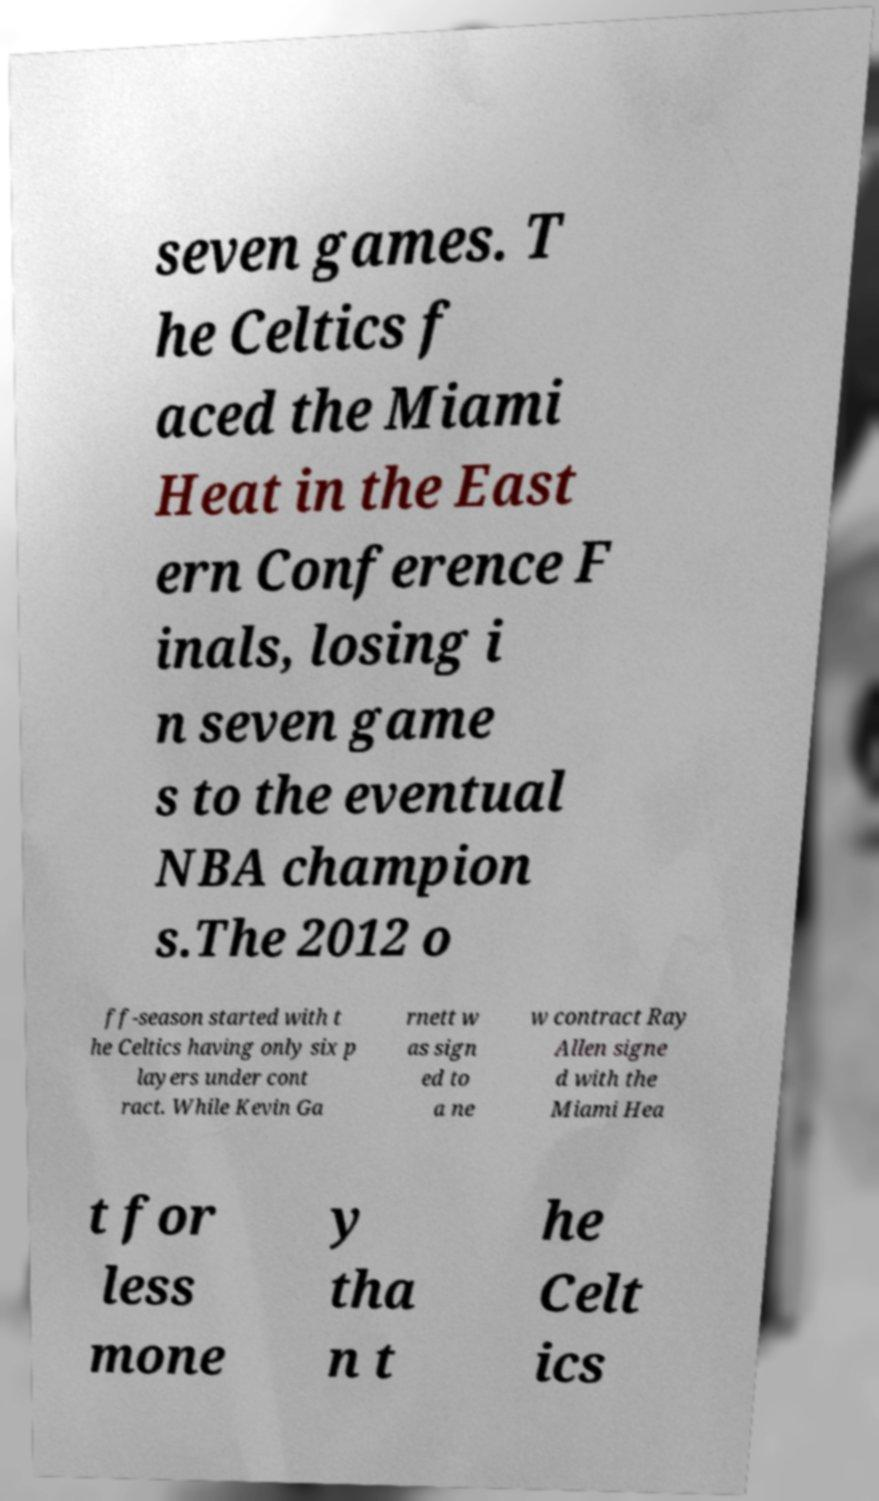There's text embedded in this image that I need extracted. Can you transcribe it verbatim? seven games. T he Celtics f aced the Miami Heat in the East ern Conference F inals, losing i n seven game s to the eventual NBA champion s.The 2012 o ff-season started with t he Celtics having only six p layers under cont ract. While Kevin Ga rnett w as sign ed to a ne w contract Ray Allen signe d with the Miami Hea t for less mone y tha n t he Celt ics 